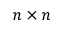<formula> <loc_0><loc_0><loc_500><loc_500>n \times n</formula> 